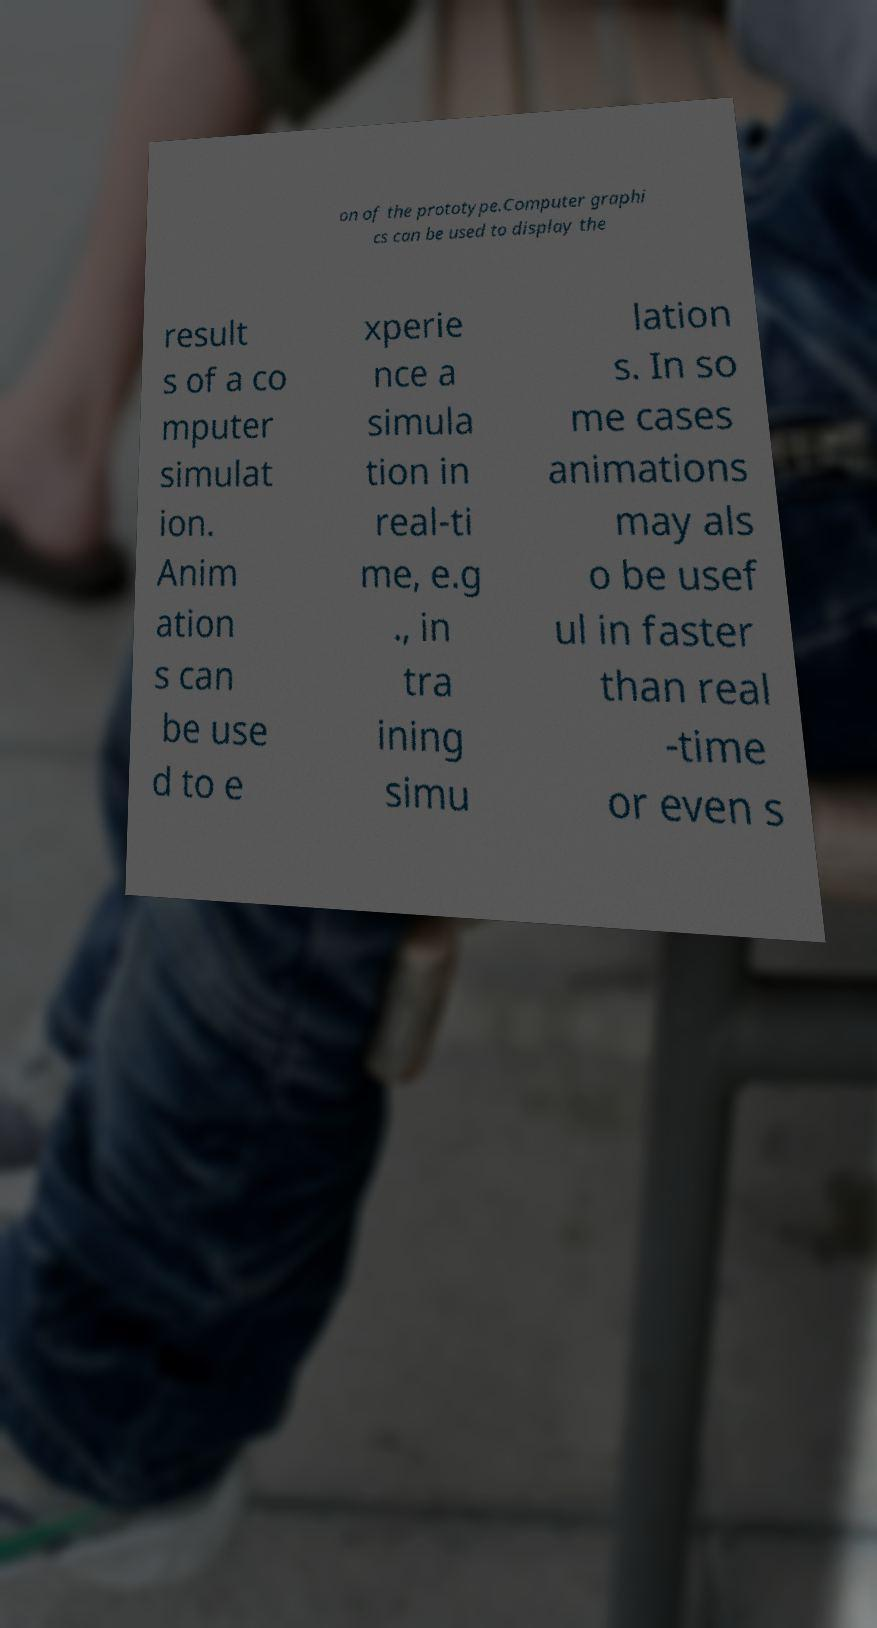Please read and relay the text visible in this image. What does it say? on of the prototype.Computer graphi cs can be used to display the result s of a co mputer simulat ion. Anim ation s can be use d to e xperie nce a simula tion in real-ti me, e.g ., in tra ining simu lation s. In so me cases animations may als o be usef ul in faster than real -time or even s 